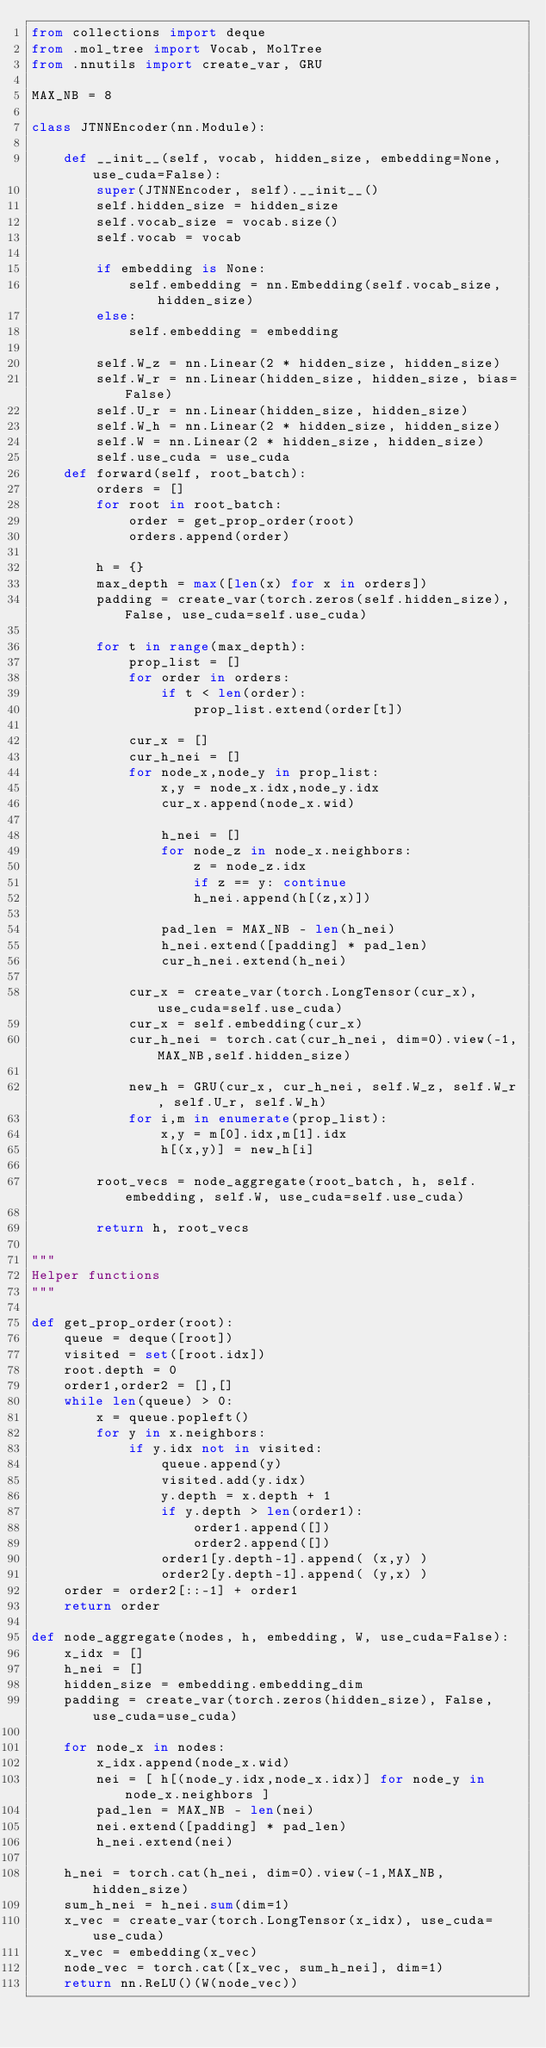Convert code to text. <code><loc_0><loc_0><loc_500><loc_500><_Python_>from collections import deque
from .mol_tree import Vocab, MolTree
from .nnutils import create_var, GRU

MAX_NB = 8

class JTNNEncoder(nn.Module):

    def __init__(self, vocab, hidden_size, embedding=None, use_cuda=False):
        super(JTNNEncoder, self).__init__()
        self.hidden_size = hidden_size
        self.vocab_size = vocab.size()
        self.vocab = vocab
        
        if embedding is None:
            self.embedding = nn.Embedding(self.vocab_size, hidden_size)
        else:
            self.embedding = embedding

        self.W_z = nn.Linear(2 * hidden_size, hidden_size)
        self.W_r = nn.Linear(hidden_size, hidden_size, bias=False)
        self.U_r = nn.Linear(hidden_size, hidden_size)
        self.W_h = nn.Linear(2 * hidden_size, hidden_size)
        self.W = nn.Linear(2 * hidden_size, hidden_size)
        self.use_cuda = use_cuda
    def forward(self, root_batch):
        orders = []
        for root in root_batch:
            order = get_prop_order(root)
            orders.append(order)
        
        h = {}
        max_depth = max([len(x) for x in orders])
        padding = create_var(torch.zeros(self.hidden_size), False, use_cuda=self.use_cuda)

        for t in range(max_depth):
            prop_list = []
            for order in orders:
                if t < len(order):
                    prop_list.extend(order[t])

            cur_x = []
            cur_h_nei = []
            for node_x,node_y in prop_list:
                x,y = node_x.idx,node_y.idx
                cur_x.append(node_x.wid)

                h_nei = []
                for node_z in node_x.neighbors:
                    z = node_z.idx
                    if z == y: continue
                    h_nei.append(h[(z,x)])

                pad_len = MAX_NB - len(h_nei)
                h_nei.extend([padding] * pad_len)
                cur_h_nei.extend(h_nei)

            cur_x = create_var(torch.LongTensor(cur_x), use_cuda=self.use_cuda)
            cur_x = self.embedding(cur_x)
            cur_h_nei = torch.cat(cur_h_nei, dim=0).view(-1,MAX_NB,self.hidden_size)

            new_h = GRU(cur_x, cur_h_nei, self.W_z, self.W_r, self.U_r, self.W_h)
            for i,m in enumerate(prop_list):
                x,y = m[0].idx,m[1].idx
                h[(x,y)] = new_h[i]

        root_vecs = node_aggregate(root_batch, h, self.embedding, self.W, use_cuda=self.use_cuda)

        return h, root_vecs

"""
Helper functions
"""

def get_prop_order(root):
    queue = deque([root])
    visited = set([root.idx])
    root.depth = 0
    order1,order2 = [],[]
    while len(queue) > 0:
        x = queue.popleft()
        for y in x.neighbors:
            if y.idx not in visited:
                queue.append(y)
                visited.add(y.idx)
                y.depth = x.depth + 1
                if y.depth > len(order1):
                    order1.append([])
                    order2.append([])
                order1[y.depth-1].append( (x,y) )
                order2[y.depth-1].append( (y,x) )
    order = order2[::-1] + order1
    return order

def node_aggregate(nodes, h, embedding, W, use_cuda=False):
    x_idx = []
    h_nei = []
    hidden_size = embedding.embedding_dim
    padding = create_var(torch.zeros(hidden_size), False, use_cuda=use_cuda)

    for node_x in nodes:
        x_idx.append(node_x.wid)
        nei = [ h[(node_y.idx,node_x.idx)] for node_y in node_x.neighbors ]
        pad_len = MAX_NB - len(nei)
        nei.extend([padding] * pad_len)
        h_nei.extend(nei)
    
    h_nei = torch.cat(h_nei, dim=0).view(-1,MAX_NB,hidden_size)
    sum_h_nei = h_nei.sum(dim=1)
    x_vec = create_var(torch.LongTensor(x_idx), use_cuda=use_cuda)
    x_vec = embedding(x_vec)
    node_vec = torch.cat([x_vec, sum_h_nei], dim=1)
    return nn.ReLU()(W(node_vec))

</code> 